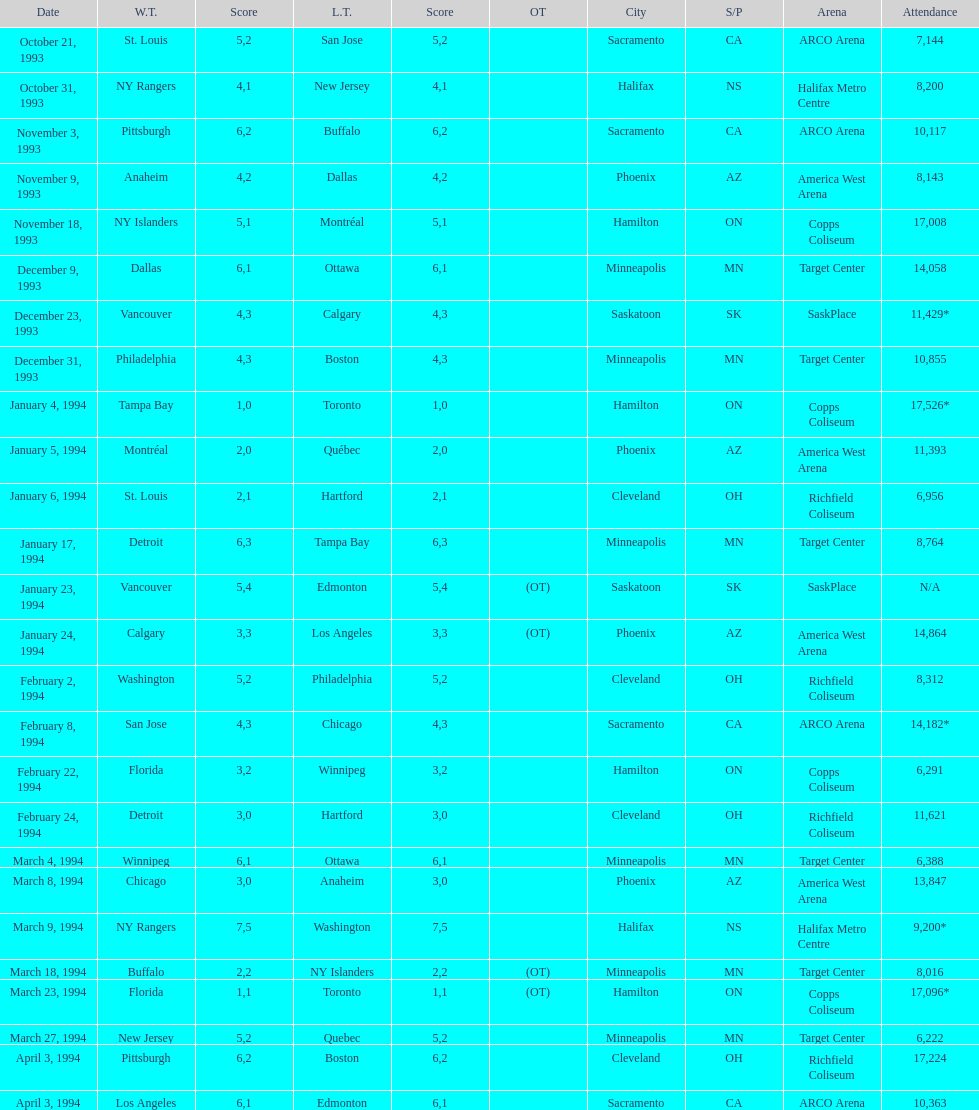Who won the game the day before the january 5, 1994 game? Tampa Bay. 